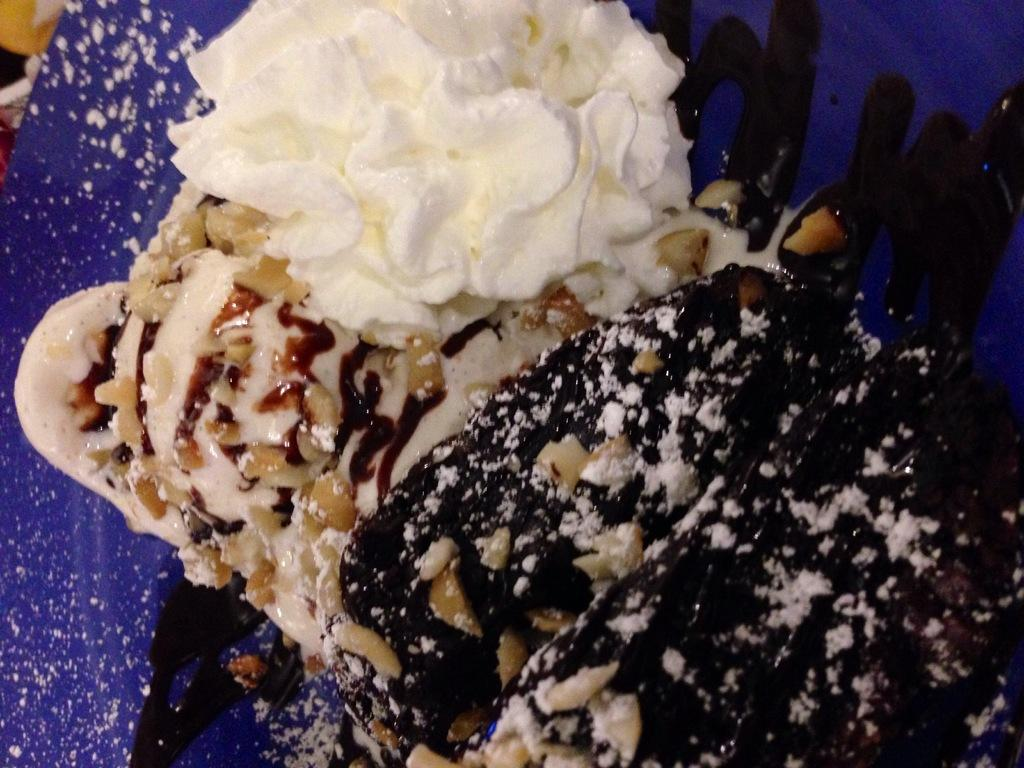What type of food item is visible in the image? There is a food item in the image that has creams and nuts on it. What colors can be seen on the food item? The food item has creams on it, which may contribute to its color. What other objects or colors can be seen in the background of the image? There is a violet color object in the background of the image. What type of vest is being worn by the person on the stage in the image? There is no person wearing a vest on a stage in the image. The image only features a food item with creams and nuts, and a violet color object in the background. 